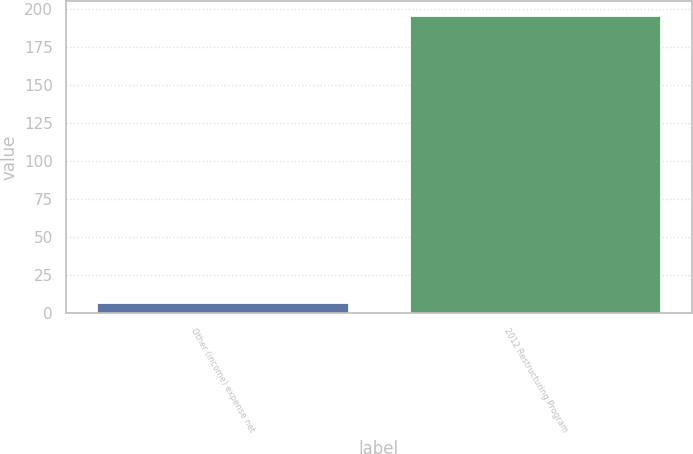Convert chart to OTSL. <chart><loc_0><loc_0><loc_500><loc_500><bar_chart><fcel>Other (income) expense net<fcel>2012 Restructuring Program<nl><fcel>7<fcel>195<nl></chart> 